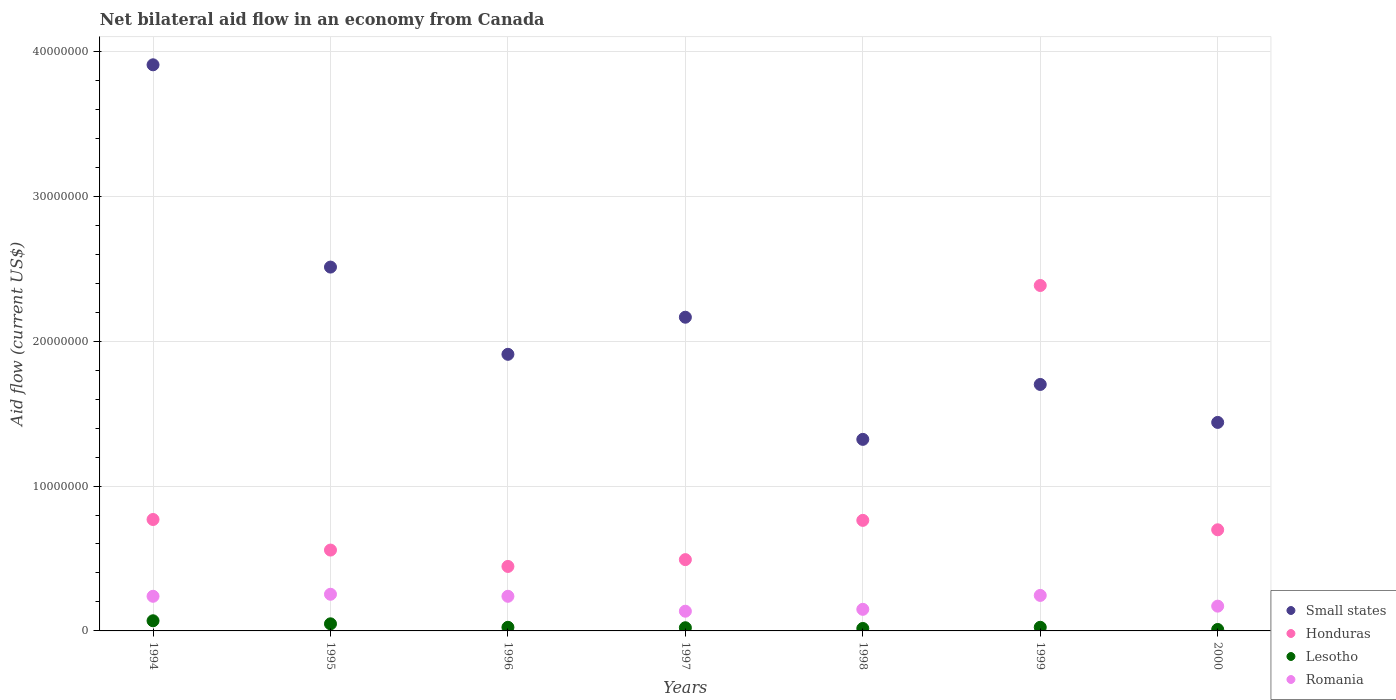How many different coloured dotlines are there?
Your answer should be compact. 4. What is the net bilateral aid flow in Lesotho in 1994?
Your response must be concise. 7.00e+05. Across all years, what is the maximum net bilateral aid flow in Honduras?
Keep it short and to the point. 2.38e+07. Across all years, what is the minimum net bilateral aid flow in Honduras?
Offer a very short reply. 4.45e+06. What is the total net bilateral aid flow in Small states in the graph?
Offer a terse response. 1.50e+08. What is the difference between the net bilateral aid flow in Honduras in 1996 and that in 2000?
Provide a succinct answer. -2.53e+06. What is the difference between the net bilateral aid flow in Lesotho in 1997 and the net bilateral aid flow in Honduras in 1996?
Your answer should be compact. -4.23e+06. What is the average net bilateral aid flow in Romania per year?
Provide a short and direct response. 2.05e+06. In the year 1998, what is the difference between the net bilateral aid flow in Lesotho and net bilateral aid flow in Small states?
Keep it short and to the point. -1.30e+07. What is the ratio of the net bilateral aid flow in Romania in 1994 to that in 1997?
Give a very brief answer. 1.76. Is the difference between the net bilateral aid flow in Lesotho in 1997 and 1998 greater than the difference between the net bilateral aid flow in Small states in 1997 and 1998?
Make the answer very short. No. What is the difference between the highest and the second highest net bilateral aid flow in Small states?
Give a very brief answer. 1.40e+07. What is the difference between the highest and the lowest net bilateral aid flow in Romania?
Your answer should be very brief. 1.17e+06. Is it the case that in every year, the sum of the net bilateral aid flow in Small states and net bilateral aid flow in Lesotho  is greater than the net bilateral aid flow in Romania?
Offer a terse response. Yes. Does the net bilateral aid flow in Small states monotonically increase over the years?
Make the answer very short. No. Is the net bilateral aid flow in Honduras strictly greater than the net bilateral aid flow in Romania over the years?
Ensure brevity in your answer.  Yes. How many dotlines are there?
Offer a very short reply. 4. Does the graph contain grids?
Your answer should be very brief. Yes. Where does the legend appear in the graph?
Your response must be concise. Bottom right. How are the legend labels stacked?
Your answer should be very brief. Vertical. What is the title of the graph?
Keep it short and to the point. Net bilateral aid flow in an economy from Canada. What is the label or title of the X-axis?
Give a very brief answer. Years. What is the Aid flow (current US$) in Small states in 1994?
Provide a succinct answer. 3.91e+07. What is the Aid flow (current US$) in Honduras in 1994?
Provide a succinct answer. 7.69e+06. What is the Aid flow (current US$) in Lesotho in 1994?
Your answer should be compact. 7.00e+05. What is the Aid flow (current US$) of Romania in 1994?
Offer a very short reply. 2.39e+06. What is the Aid flow (current US$) of Small states in 1995?
Offer a very short reply. 2.51e+07. What is the Aid flow (current US$) in Honduras in 1995?
Your answer should be compact. 5.58e+06. What is the Aid flow (current US$) in Lesotho in 1995?
Give a very brief answer. 4.90e+05. What is the Aid flow (current US$) in Romania in 1995?
Your answer should be compact. 2.53e+06. What is the Aid flow (current US$) in Small states in 1996?
Offer a terse response. 1.91e+07. What is the Aid flow (current US$) of Honduras in 1996?
Provide a short and direct response. 4.45e+06. What is the Aid flow (current US$) in Lesotho in 1996?
Your answer should be very brief. 2.50e+05. What is the Aid flow (current US$) in Romania in 1996?
Your answer should be very brief. 2.39e+06. What is the Aid flow (current US$) of Small states in 1997?
Keep it short and to the point. 2.16e+07. What is the Aid flow (current US$) in Honduras in 1997?
Provide a short and direct response. 4.92e+06. What is the Aid flow (current US$) of Lesotho in 1997?
Give a very brief answer. 2.20e+05. What is the Aid flow (current US$) of Romania in 1997?
Offer a very short reply. 1.36e+06. What is the Aid flow (current US$) in Small states in 1998?
Your answer should be very brief. 1.32e+07. What is the Aid flow (current US$) of Honduras in 1998?
Make the answer very short. 7.63e+06. What is the Aid flow (current US$) in Lesotho in 1998?
Give a very brief answer. 1.70e+05. What is the Aid flow (current US$) of Romania in 1998?
Provide a short and direct response. 1.49e+06. What is the Aid flow (current US$) of Small states in 1999?
Provide a short and direct response. 1.70e+07. What is the Aid flow (current US$) of Honduras in 1999?
Provide a short and direct response. 2.38e+07. What is the Aid flow (current US$) of Romania in 1999?
Provide a succinct answer. 2.45e+06. What is the Aid flow (current US$) in Small states in 2000?
Your answer should be very brief. 1.44e+07. What is the Aid flow (current US$) of Honduras in 2000?
Ensure brevity in your answer.  6.98e+06. What is the Aid flow (current US$) of Lesotho in 2000?
Make the answer very short. 1.00e+05. What is the Aid flow (current US$) of Romania in 2000?
Give a very brief answer. 1.71e+06. Across all years, what is the maximum Aid flow (current US$) of Small states?
Provide a short and direct response. 3.91e+07. Across all years, what is the maximum Aid flow (current US$) of Honduras?
Ensure brevity in your answer.  2.38e+07. Across all years, what is the maximum Aid flow (current US$) of Romania?
Your answer should be compact. 2.53e+06. Across all years, what is the minimum Aid flow (current US$) of Small states?
Make the answer very short. 1.32e+07. Across all years, what is the minimum Aid flow (current US$) in Honduras?
Your answer should be very brief. 4.45e+06. Across all years, what is the minimum Aid flow (current US$) in Lesotho?
Provide a succinct answer. 1.00e+05. Across all years, what is the minimum Aid flow (current US$) of Romania?
Provide a short and direct response. 1.36e+06. What is the total Aid flow (current US$) of Small states in the graph?
Ensure brevity in your answer.  1.50e+08. What is the total Aid flow (current US$) in Honduras in the graph?
Your answer should be very brief. 6.11e+07. What is the total Aid flow (current US$) in Lesotho in the graph?
Your answer should be compact. 2.18e+06. What is the total Aid flow (current US$) of Romania in the graph?
Your answer should be very brief. 1.43e+07. What is the difference between the Aid flow (current US$) in Small states in 1994 and that in 1995?
Provide a short and direct response. 1.40e+07. What is the difference between the Aid flow (current US$) of Honduras in 1994 and that in 1995?
Offer a very short reply. 2.11e+06. What is the difference between the Aid flow (current US$) in Romania in 1994 and that in 1995?
Ensure brevity in your answer.  -1.40e+05. What is the difference between the Aid flow (current US$) in Small states in 1994 and that in 1996?
Your answer should be very brief. 2.00e+07. What is the difference between the Aid flow (current US$) of Honduras in 1994 and that in 1996?
Offer a very short reply. 3.24e+06. What is the difference between the Aid flow (current US$) of Small states in 1994 and that in 1997?
Offer a terse response. 1.74e+07. What is the difference between the Aid flow (current US$) in Honduras in 1994 and that in 1997?
Offer a very short reply. 2.77e+06. What is the difference between the Aid flow (current US$) of Lesotho in 1994 and that in 1997?
Provide a succinct answer. 4.80e+05. What is the difference between the Aid flow (current US$) in Romania in 1994 and that in 1997?
Offer a very short reply. 1.03e+06. What is the difference between the Aid flow (current US$) in Small states in 1994 and that in 1998?
Provide a succinct answer. 2.58e+07. What is the difference between the Aid flow (current US$) in Lesotho in 1994 and that in 1998?
Provide a succinct answer. 5.30e+05. What is the difference between the Aid flow (current US$) of Small states in 1994 and that in 1999?
Provide a succinct answer. 2.21e+07. What is the difference between the Aid flow (current US$) of Honduras in 1994 and that in 1999?
Your answer should be very brief. -1.62e+07. What is the difference between the Aid flow (current US$) in Lesotho in 1994 and that in 1999?
Your response must be concise. 4.50e+05. What is the difference between the Aid flow (current US$) of Small states in 1994 and that in 2000?
Make the answer very short. 2.47e+07. What is the difference between the Aid flow (current US$) of Honduras in 1994 and that in 2000?
Your answer should be compact. 7.10e+05. What is the difference between the Aid flow (current US$) in Lesotho in 1994 and that in 2000?
Offer a very short reply. 6.00e+05. What is the difference between the Aid flow (current US$) in Romania in 1994 and that in 2000?
Offer a terse response. 6.80e+05. What is the difference between the Aid flow (current US$) in Small states in 1995 and that in 1996?
Provide a succinct answer. 6.02e+06. What is the difference between the Aid flow (current US$) in Honduras in 1995 and that in 1996?
Offer a very short reply. 1.13e+06. What is the difference between the Aid flow (current US$) in Romania in 1995 and that in 1996?
Ensure brevity in your answer.  1.40e+05. What is the difference between the Aid flow (current US$) of Small states in 1995 and that in 1997?
Make the answer very short. 3.46e+06. What is the difference between the Aid flow (current US$) in Romania in 1995 and that in 1997?
Your answer should be compact. 1.17e+06. What is the difference between the Aid flow (current US$) of Small states in 1995 and that in 1998?
Your answer should be compact. 1.19e+07. What is the difference between the Aid flow (current US$) in Honduras in 1995 and that in 1998?
Your answer should be very brief. -2.05e+06. What is the difference between the Aid flow (current US$) of Lesotho in 1995 and that in 1998?
Provide a short and direct response. 3.20e+05. What is the difference between the Aid flow (current US$) in Romania in 1995 and that in 1998?
Offer a terse response. 1.04e+06. What is the difference between the Aid flow (current US$) in Small states in 1995 and that in 1999?
Offer a terse response. 8.10e+06. What is the difference between the Aid flow (current US$) of Honduras in 1995 and that in 1999?
Keep it short and to the point. -1.83e+07. What is the difference between the Aid flow (current US$) in Lesotho in 1995 and that in 1999?
Ensure brevity in your answer.  2.40e+05. What is the difference between the Aid flow (current US$) of Romania in 1995 and that in 1999?
Provide a succinct answer. 8.00e+04. What is the difference between the Aid flow (current US$) of Small states in 1995 and that in 2000?
Make the answer very short. 1.07e+07. What is the difference between the Aid flow (current US$) of Honduras in 1995 and that in 2000?
Make the answer very short. -1.40e+06. What is the difference between the Aid flow (current US$) in Lesotho in 1995 and that in 2000?
Your response must be concise. 3.90e+05. What is the difference between the Aid flow (current US$) in Romania in 1995 and that in 2000?
Provide a short and direct response. 8.20e+05. What is the difference between the Aid flow (current US$) of Small states in 1996 and that in 1997?
Give a very brief answer. -2.56e+06. What is the difference between the Aid flow (current US$) of Honduras in 1996 and that in 1997?
Offer a terse response. -4.70e+05. What is the difference between the Aid flow (current US$) in Romania in 1996 and that in 1997?
Your answer should be very brief. 1.03e+06. What is the difference between the Aid flow (current US$) in Small states in 1996 and that in 1998?
Give a very brief answer. 5.87e+06. What is the difference between the Aid flow (current US$) in Honduras in 1996 and that in 1998?
Offer a very short reply. -3.18e+06. What is the difference between the Aid flow (current US$) of Lesotho in 1996 and that in 1998?
Your answer should be very brief. 8.00e+04. What is the difference between the Aid flow (current US$) in Small states in 1996 and that in 1999?
Keep it short and to the point. 2.08e+06. What is the difference between the Aid flow (current US$) in Honduras in 1996 and that in 1999?
Ensure brevity in your answer.  -1.94e+07. What is the difference between the Aid flow (current US$) of Romania in 1996 and that in 1999?
Provide a short and direct response. -6.00e+04. What is the difference between the Aid flow (current US$) in Small states in 1996 and that in 2000?
Keep it short and to the point. 4.70e+06. What is the difference between the Aid flow (current US$) of Honduras in 1996 and that in 2000?
Your response must be concise. -2.53e+06. What is the difference between the Aid flow (current US$) of Romania in 1996 and that in 2000?
Provide a succinct answer. 6.80e+05. What is the difference between the Aid flow (current US$) of Small states in 1997 and that in 1998?
Ensure brevity in your answer.  8.43e+06. What is the difference between the Aid flow (current US$) in Honduras in 1997 and that in 1998?
Provide a succinct answer. -2.71e+06. What is the difference between the Aid flow (current US$) of Small states in 1997 and that in 1999?
Ensure brevity in your answer.  4.64e+06. What is the difference between the Aid flow (current US$) of Honduras in 1997 and that in 1999?
Offer a terse response. -1.89e+07. What is the difference between the Aid flow (current US$) of Lesotho in 1997 and that in 1999?
Your answer should be very brief. -3.00e+04. What is the difference between the Aid flow (current US$) in Romania in 1997 and that in 1999?
Your answer should be very brief. -1.09e+06. What is the difference between the Aid flow (current US$) of Small states in 1997 and that in 2000?
Your answer should be compact. 7.26e+06. What is the difference between the Aid flow (current US$) in Honduras in 1997 and that in 2000?
Offer a terse response. -2.06e+06. What is the difference between the Aid flow (current US$) of Lesotho in 1997 and that in 2000?
Ensure brevity in your answer.  1.20e+05. What is the difference between the Aid flow (current US$) of Romania in 1997 and that in 2000?
Keep it short and to the point. -3.50e+05. What is the difference between the Aid flow (current US$) in Small states in 1998 and that in 1999?
Provide a short and direct response. -3.79e+06. What is the difference between the Aid flow (current US$) of Honduras in 1998 and that in 1999?
Ensure brevity in your answer.  -1.62e+07. What is the difference between the Aid flow (current US$) in Romania in 1998 and that in 1999?
Your answer should be very brief. -9.60e+05. What is the difference between the Aid flow (current US$) in Small states in 1998 and that in 2000?
Offer a terse response. -1.17e+06. What is the difference between the Aid flow (current US$) in Honduras in 1998 and that in 2000?
Provide a succinct answer. 6.50e+05. What is the difference between the Aid flow (current US$) in Small states in 1999 and that in 2000?
Offer a very short reply. 2.62e+06. What is the difference between the Aid flow (current US$) of Honduras in 1999 and that in 2000?
Your answer should be very brief. 1.69e+07. What is the difference between the Aid flow (current US$) in Lesotho in 1999 and that in 2000?
Offer a very short reply. 1.50e+05. What is the difference between the Aid flow (current US$) in Romania in 1999 and that in 2000?
Offer a terse response. 7.40e+05. What is the difference between the Aid flow (current US$) in Small states in 1994 and the Aid flow (current US$) in Honduras in 1995?
Your answer should be compact. 3.35e+07. What is the difference between the Aid flow (current US$) of Small states in 1994 and the Aid flow (current US$) of Lesotho in 1995?
Offer a terse response. 3.86e+07. What is the difference between the Aid flow (current US$) of Small states in 1994 and the Aid flow (current US$) of Romania in 1995?
Provide a short and direct response. 3.65e+07. What is the difference between the Aid flow (current US$) of Honduras in 1994 and the Aid flow (current US$) of Lesotho in 1995?
Provide a succinct answer. 7.20e+06. What is the difference between the Aid flow (current US$) in Honduras in 1994 and the Aid flow (current US$) in Romania in 1995?
Give a very brief answer. 5.16e+06. What is the difference between the Aid flow (current US$) of Lesotho in 1994 and the Aid flow (current US$) of Romania in 1995?
Give a very brief answer. -1.83e+06. What is the difference between the Aid flow (current US$) in Small states in 1994 and the Aid flow (current US$) in Honduras in 1996?
Provide a succinct answer. 3.46e+07. What is the difference between the Aid flow (current US$) in Small states in 1994 and the Aid flow (current US$) in Lesotho in 1996?
Make the answer very short. 3.88e+07. What is the difference between the Aid flow (current US$) of Small states in 1994 and the Aid flow (current US$) of Romania in 1996?
Your answer should be compact. 3.67e+07. What is the difference between the Aid flow (current US$) of Honduras in 1994 and the Aid flow (current US$) of Lesotho in 1996?
Offer a very short reply. 7.44e+06. What is the difference between the Aid flow (current US$) of Honduras in 1994 and the Aid flow (current US$) of Romania in 1996?
Provide a succinct answer. 5.30e+06. What is the difference between the Aid flow (current US$) of Lesotho in 1994 and the Aid flow (current US$) of Romania in 1996?
Make the answer very short. -1.69e+06. What is the difference between the Aid flow (current US$) of Small states in 1994 and the Aid flow (current US$) of Honduras in 1997?
Make the answer very short. 3.42e+07. What is the difference between the Aid flow (current US$) of Small states in 1994 and the Aid flow (current US$) of Lesotho in 1997?
Ensure brevity in your answer.  3.88e+07. What is the difference between the Aid flow (current US$) in Small states in 1994 and the Aid flow (current US$) in Romania in 1997?
Provide a short and direct response. 3.77e+07. What is the difference between the Aid flow (current US$) of Honduras in 1994 and the Aid flow (current US$) of Lesotho in 1997?
Give a very brief answer. 7.47e+06. What is the difference between the Aid flow (current US$) in Honduras in 1994 and the Aid flow (current US$) in Romania in 1997?
Ensure brevity in your answer.  6.33e+06. What is the difference between the Aid flow (current US$) in Lesotho in 1994 and the Aid flow (current US$) in Romania in 1997?
Ensure brevity in your answer.  -6.60e+05. What is the difference between the Aid flow (current US$) in Small states in 1994 and the Aid flow (current US$) in Honduras in 1998?
Your answer should be very brief. 3.14e+07. What is the difference between the Aid flow (current US$) in Small states in 1994 and the Aid flow (current US$) in Lesotho in 1998?
Provide a succinct answer. 3.89e+07. What is the difference between the Aid flow (current US$) of Small states in 1994 and the Aid flow (current US$) of Romania in 1998?
Keep it short and to the point. 3.76e+07. What is the difference between the Aid flow (current US$) of Honduras in 1994 and the Aid flow (current US$) of Lesotho in 1998?
Keep it short and to the point. 7.52e+06. What is the difference between the Aid flow (current US$) of Honduras in 1994 and the Aid flow (current US$) of Romania in 1998?
Offer a very short reply. 6.20e+06. What is the difference between the Aid flow (current US$) in Lesotho in 1994 and the Aid flow (current US$) in Romania in 1998?
Ensure brevity in your answer.  -7.90e+05. What is the difference between the Aid flow (current US$) in Small states in 1994 and the Aid flow (current US$) in Honduras in 1999?
Give a very brief answer. 1.52e+07. What is the difference between the Aid flow (current US$) in Small states in 1994 and the Aid flow (current US$) in Lesotho in 1999?
Keep it short and to the point. 3.88e+07. What is the difference between the Aid flow (current US$) of Small states in 1994 and the Aid flow (current US$) of Romania in 1999?
Make the answer very short. 3.66e+07. What is the difference between the Aid flow (current US$) in Honduras in 1994 and the Aid flow (current US$) in Lesotho in 1999?
Make the answer very short. 7.44e+06. What is the difference between the Aid flow (current US$) in Honduras in 1994 and the Aid flow (current US$) in Romania in 1999?
Offer a very short reply. 5.24e+06. What is the difference between the Aid flow (current US$) in Lesotho in 1994 and the Aid flow (current US$) in Romania in 1999?
Your answer should be very brief. -1.75e+06. What is the difference between the Aid flow (current US$) in Small states in 1994 and the Aid flow (current US$) in Honduras in 2000?
Offer a very short reply. 3.21e+07. What is the difference between the Aid flow (current US$) in Small states in 1994 and the Aid flow (current US$) in Lesotho in 2000?
Make the answer very short. 3.90e+07. What is the difference between the Aid flow (current US$) in Small states in 1994 and the Aid flow (current US$) in Romania in 2000?
Offer a terse response. 3.74e+07. What is the difference between the Aid flow (current US$) of Honduras in 1994 and the Aid flow (current US$) of Lesotho in 2000?
Your answer should be compact. 7.59e+06. What is the difference between the Aid flow (current US$) of Honduras in 1994 and the Aid flow (current US$) of Romania in 2000?
Ensure brevity in your answer.  5.98e+06. What is the difference between the Aid flow (current US$) of Lesotho in 1994 and the Aid flow (current US$) of Romania in 2000?
Your answer should be very brief. -1.01e+06. What is the difference between the Aid flow (current US$) of Small states in 1995 and the Aid flow (current US$) of Honduras in 1996?
Keep it short and to the point. 2.07e+07. What is the difference between the Aid flow (current US$) in Small states in 1995 and the Aid flow (current US$) in Lesotho in 1996?
Give a very brief answer. 2.49e+07. What is the difference between the Aid flow (current US$) in Small states in 1995 and the Aid flow (current US$) in Romania in 1996?
Provide a succinct answer. 2.27e+07. What is the difference between the Aid flow (current US$) in Honduras in 1995 and the Aid flow (current US$) in Lesotho in 1996?
Make the answer very short. 5.33e+06. What is the difference between the Aid flow (current US$) in Honduras in 1995 and the Aid flow (current US$) in Romania in 1996?
Ensure brevity in your answer.  3.19e+06. What is the difference between the Aid flow (current US$) in Lesotho in 1995 and the Aid flow (current US$) in Romania in 1996?
Provide a succinct answer. -1.90e+06. What is the difference between the Aid flow (current US$) in Small states in 1995 and the Aid flow (current US$) in Honduras in 1997?
Your response must be concise. 2.02e+07. What is the difference between the Aid flow (current US$) of Small states in 1995 and the Aid flow (current US$) of Lesotho in 1997?
Your answer should be very brief. 2.49e+07. What is the difference between the Aid flow (current US$) of Small states in 1995 and the Aid flow (current US$) of Romania in 1997?
Offer a terse response. 2.38e+07. What is the difference between the Aid flow (current US$) in Honduras in 1995 and the Aid flow (current US$) in Lesotho in 1997?
Your response must be concise. 5.36e+06. What is the difference between the Aid flow (current US$) of Honduras in 1995 and the Aid flow (current US$) of Romania in 1997?
Provide a short and direct response. 4.22e+06. What is the difference between the Aid flow (current US$) in Lesotho in 1995 and the Aid flow (current US$) in Romania in 1997?
Keep it short and to the point. -8.70e+05. What is the difference between the Aid flow (current US$) of Small states in 1995 and the Aid flow (current US$) of Honduras in 1998?
Offer a very short reply. 1.75e+07. What is the difference between the Aid flow (current US$) of Small states in 1995 and the Aid flow (current US$) of Lesotho in 1998?
Ensure brevity in your answer.  2.49e+07. What is the difference between the Aid flow (current US$) in Small states in 1995 and the Aid flow (current US$) in Romania in 1998?
Your response must be concise. 2.36e+07. What is the difference between the Aid flow (current US$) in Honduras in 1995 and the Aid flow (current US$) in Lesotho in 1998?
Offer a very short reply. 5.41e+06. What is the difference between the Aid flow (current US$) in Honduras in 1995 and the Aid flow (current US$) in Romania in 1998?
Offer a terse response. 4.09e+06. What is the difference between the Aid flow (current US$) of Small states in 1995 and the Aid flow (current US$) of Honduras in 1999?
Give a very brief answer. 1.27e+06. What is the difference between the Aid flow (current US$) in Small states in 1995 and the Aid flow (current US$) in Lesotho in 1999?
Your response must be concise. 2.49e+07. What is the difference between the Aid flow (current US$) of Small states in 1995 and the Aid flow (current US$) of Romania in 1999?
Your answer should be very brief. 2.27e+07. What is the difference between the Aid flow (current US$) of Honduras in 1995 and the Aid flow (current US$) of Lesotho in 1999?
Make the answer very short. 5.33e+06. What is the difference between the Aid flow (current US$) in Honduras in 1995 and the Aid flow (current US$) in Romania in 1999?
Ensure brevity in your answer.  3.13e+06. What is the difference between the Aid flow (current US$) in Lesotho in 1995 and the Aid flow (current US$) in Romania in 1999?
Provide a short and direct response. -1.96e+06. What is the difference between the Aid flow (current US$) in Small states in 1995 and the Aid flow (current US$) in Honduras in 2000?
Offer a very short reply. 1.81e+07. What is the difference between the Aid flow (current US$) in Small states in 1995 and the Aid flow (current US$) in Lesotho in 2000?
Offer a very short reply. 2.50e+07. What is the difference between the Aid flow (current US$) of Small states in 1995 and the Aid flow (current US$) of Romania in 2000?
Keep it short and to the point. 2.34e+07. What is the difference between the Aid flow (current US$) of Honduras in 1995 and the Aid flow (current US$) of Lesotho in 2000?
Make the answer very short. 5.48e+06. What is the difference between the Aid flow (current US$) in Honduras in 1995 and the Aid flow (current US$) in Romania in 2000?
Provide a succinct answer. 3.87e+06. What is the difference between the Aid flow (current US$) in Lesotho in 1995 and the Aid flow (current US$) in Romania in 2000?
Your answer should be very brief. -1.22e+06. What is the difference between the Aid flow (current US$) in Small states in 1996 and the Aid flow (current US$) in Honduras in 1997?
Offer a very short reply. 1.42e+07. What is the difference between the Aid flow (current US$) in Small states in 1996 and the Aid flow (current US$) in Lesotho in 1997?
Your answer should be compact. 1.89e+07. What is the difference between the Aid flow (current US$) of Small states in 1996 and the Aid flow (current US$) of Romania in 1997?
Offer a terse response. 1.77e+07. What is the difference between the Aid flow (current US$) in Honduras in 1996 and the Aid flow (current US$) in Lesotho in 1997?
Your answer should be very brief. 4.23e+06. What is the difference between the Aid flow (current US$) in Honduras in 1996 and the Aid flow (current US$) in Romania in 1997?
Keep it short and to the point. 3.09e+06. What is the difference between the Aid flow (current US$) in Lesotho in 1996 and the Aid flow (current US$) in Romania in 1997?
Keep it short and to the point. -1.11e+06. What is the difference between the Aid flow (current US$) of Small states in 1996 and the Aid flow (current US$) of Honduras in 1998?
Keep it short and to the point. 1.15e+07. What is the difference between the Aid flow (current US$) of Small states in 1996 and the Aid flow (current US$) of Lesotho in 1998?
Keep it short and to the point. 1.89e+07. What is the difference between the Aid flow (current US$) in Small states in 1996 and the Aid flow (current US$) in Romania in 1998?
Your response must be concise. 1.76e+07. What is the difference between the Aid flow (current US$) in Honduras in 1996 and the Aid flow (current US$) in Lesotho in 1998?
Give a very brief answer. 4.28e+06. What is the difference between the Aid flow (current US$) in Honduras in 1996 and the Aid flow (current US$) in Romania in 1998?
Give a very brief answer. 2.96e+06. What is the difference between the Aid flow (current US$) of Lesotho in 1996 and the Aid flow (current US$) of Romania in 1998?
Your answer should be compact. -1.24e+06. What is the difference between the Aid flow (current US$) in Small states in 1996 and the Aid flow (current US$) in Honduras in 1999?
Offer a very short reply. -4.75e+06. What is the difference between the Aid flow (current US$) of Small states in 1996 and the Aid flow (current US$) of Lesotho in 1999?
Your answer should be very brief. 1.88e+07. What is the difference between the Aid flow (current US$) in Small states in 1996 and the Aid flow (current US$) in Romania in 1999?
Your answer should be compact. 1.66e+07. What is the difference between the Aid flow (current US$) in Honduras in 1996 and the Aid flow (current US$) in Lesotho in 1999?
Provide a succinct answer. 4.20e+06. What is the difference between the Aid flow (current US$) of Lesotho in 1996 and the Aid flow (current US$) of Romania in 1999?
Ensure brevity in your answer.  -2.20e+06. What is the difference between the Aid flow (current US$) of Small states in 1996 and the Aid flow (current US$) of Honduras in 2000?
Keep it short and to the point. 1.21e+07. What is the difference between the Aid flow (current US$) in Small states in 1996 and the Aid flow (current US$) in Lesotho in 2000?
Your answer should be compact. 1.90e+07. What is the difference between the Aid flow (current US$) in Small states in 1996 and the Aid flow (current US$) in Romania in 2000?
Your answer should be very brief. 1.74e+07. What is the difference between the Aid flow (current US$) of Honduras in 1996 and the Aid flow (current US$) of Lesotho in 2000?
Your response must be concise. 4.35e+06. What is the difference between the Aid flow (current US$) of Honduras in 1996 and the Aid flow (current US$) of Romania in 2000?
Provide a succinct answer. 2.74e+06. What is the difference between the Aid flow (current US$) of Lesotho in 1996 and the Aid flow (current US$) of Romania in 2000?
Your answer should be compact. -1.46e+06. What is the difference between the Aid flow (current US$) in Small states in 1997 and the Aid flow (current US$) in Honduras in 1998?
Keep it short and to the point. 1.40e+07. What is the difference between the Aid flow (current US$) of Small states in 1997 and the Aid flow (current US$) of Lesotho in 1998?
Offer a very short reply. 2.15e+07. What is the difference between the Aid flow (current US$) of Small states in 1997 and the Aid flow (current US$) of Romania in 1998?
Your response must be concise. 2.02e+07. What is the difference between the Aid flow (current US$) of Honduras in 1997 and the Aid flow (current US$) of Lesotho in 1998?
Keep it short and to the point. 4.75e+06. What is the difference between the Aid flow (current US$) of Honduras in 1997 and the Aid flow (current US$) of Romania in 1998?
Your answer should be compact. 3.43e+06. What is the difference between the Aid flow (current US$) of Lesotho in 1997 and the Aid flow (current US$) of Romania in 1998?
Your answer should be compact. -1.27e+06. What is the difference between the Aid flow (current US$) in Small states in 1997 and the Aid flow (current US$) in Honduras in 1999?
Make the answer very short. -2.19e+06. What is the difference between the Aid flow (current US$) in Small states in 1997 and the Aid flow (current US$) in Lesotho in 1999?
Make the answer very short. 2.14e+07. What is the difference between the Aid flow (current US$) in Small states in 1997 and the Aid flow (current US$) in Romania in 1999?
Ensure brevity in your answer.  1.92e+07. What is the difference between the Aid flow (current US$) in Honduras in 1997 and the Aid flow (current US$) in Lesotho in 1999?
Provide a succinct answer. 4.67e+06. What is the difference between the Aid flow (current US$) in Honduras in 1997 and the Aid flow (current US$) in Romania in 1999?
Ensure brevity in your answer.  2.47e+06. What is the difference between the Aid flow (current US$) in Lesotho in 1997 and the Aid flow (current US$) in Romania in 1999?
Provide a succinct answer. -2.23e+06. What is the difference between the Aid flow (current US$) of Small states in 1997 and the Aid flow (current US$) of Honduras in 2000?
Provide a short and direct response. 1.47e+07. What is the difference between the Aid flow (current US$) of Small states in 1997 and the Aid flow (current US$) of Lesotho in 2000?
Give a very brief answer. 2.16e+07. What is the difference between the Aid flow (current US$) of Small states in 1997 and the Aid flow (current US$) of Romania in 2000?
Provide a succinct answer. 1.99e+07. What is the difference between the Aid flow (current US$) of Honduras in 1997 and the Aid flow (current US$) of Lesotho in 2000?
Provide a succinct answer. 4.82e+06. What is the difference between the Aid flow (current US$) of Honduras in 1997 and the Aid flow (current US$) of Romania in 2000?
Offer a terse response. 3.21e+06. What is the difference between the Aid flow (current US$) in Lesotho in 1997 and the Aid flow (current US$) in Romania in 2000?
Give a very brief answer. -1.49e+06. What is the difference between the Aid flow (current US$) of Small states in 1998 and the Aid flow (current US$) of Honduras in 1999?
Keep it short and to the point. -1.06e+07. What is the difference between the Aid flow (current US$) in Small states in 1998 and the Aid flow (current US$) in Lesotho in 1999?
Give a very brief answer. 1.30e+07. What is the difference between the Aid flow (current US$) of Small states in 1998 and the Aid flow (current US$) of Romania in 1999?
Give a very brief answer. 1.08e+07. What is the difference between the Aid flow (current US$) of Honduras in 1998 and the Aid flow (current US$) of Lesotho in 1999?
Offer a terse response. 7.38e+06. What is the difference between the Aid flow (current US$) in Honduras in 1998 and the Aid flow (current US$) in Romania in 1999?
Your answer should be very brief. 5.18e+06. What is the difference between the Aid flow (current US$) in Lesotho in 1998 and the Aid flow (current US$) in Romania in 1999?
Offer a terse response. -2.28e+06. What is the difference between the Aid flow (current US$) of Small states in 1998 and the Aid flow (current US$) of Honduras in 2000?
Your answer should be very brief. 6.24e+06. What is the difference between the Aid flow (current US$) of Small states in 1998 and the Aid flow (current US$) of Lesotho in 2000?
Offer a terse response. 1.31e+07. What is the difference between the Aid flow (current US$) of Small states in 1998 and the Aid flow (current US$) of Romania in 2000?
Offer a terse response. 1.15e+07. What is the difference between the Aid flow (current US$) in Honduras in 1998 and the Aid flow (current US$) in Lesotho in 2000?
Provide a succinct answer. 7.53e+06. What is the difference between the Aid flow (current US$) in Honduras in 1998 and the Aid flow (current US$) in Romania in 2000?
Give a very brief answer. 5.92e+06. What is the difference between the Aid flow (current US$) of Lesotho in 1998 and the Aid flow (current US$) of Romania in 2000?
Your answer should be very brief. -1.54e+06. What is the difference between the Aid flow (current US$) of Small states in 1999 and the Aid flow (current US$) of Honduras in 2000?
Ensure brevity in your answer.  1.00e+07. What is the difference between the Aid flow (current US$) in Small states in 1999 and the Aid flow (current US$) in Lesotho in 2000?
Offer a terse response. 1.69e+07. What is the difference between the Aid flow (current US$) in Small states in 1999 and the Aid flow (current US$) in Romania in 2000?
Make the answer very short. 1.53e+07. What is the difference between the Aid flow (current US$) of Honduras in 1999 and the Aid flow (current US$) of Lesotho in 2000?
Give a very brief answer. 2.37e+07. What is the difference between the Aid flow (current US$) in Honduras in 1999 and the Aid flow (current US$) in Romania in 2000?
Give a very brief answer. 2.21e+07. What is the difference between the Aid flow (current US$) of Lesotho in 1999 and the Aid flow (current US$) of Romania in 2000?
Offer a terse response. -1.46e+06. What is the average Aid flow (current US$) in Small states per year?
Offer a very short reply. 2.14e+07. What is the average Aid flow (current US$) in Honduras per year?
Your answer should be compact. 8.73e+06. What is the average Aid flow (current US$) of Lesotho per year?
Your answer should be very brief. 3.11e+05. What is the average Aid flow (current US$) of Romania per year?
Make the answer very short. 2.05e+06. In the year 1994, what is the difference between the Aid flow (current US$) of Small states and Aid flow (current US$) of Honduras?
Make the answer very short. 3.14e+07. In the year 1994, what is the difference between the Aid flow (current US$) of Small states and Aid flow (current US$) of Lesotho?
Make the answer very short. 3.84e+07. In the year 1994, what is the difference between the Aid flow (current US$) in Small states and Aid flow (current US$) in Romania?
Provide a succinct answer. 3.67e+07. In the year 1994, what is the difference between the Aid flow (current US$) of Honduras and Aid flow (current US$) of Lesotho?
Your answer should be compact. 6.99e+06. In the year 1994, what is the difference between the Aid flow (current US$) of Honduras and Aid flow (current US$) of Romania?
Provide a short and direct response. 5.30e+06. In the year 1994, what is the difference between the Aid flow (current US$) of Lesotho and Aid flow (current US$) of Romania?
Keep it short and to the point. -1.69e+06. In the year 1995, what is the difference between the Aid flow (current US$) in Small states and Aid flow (current US$) in Honduras?
Your answer should be compact. 1.95e+07. In the year 1995, what is the difference between the Aid flow (current US$) in Small states and Aid flow (current US$) in Lesotho?
Make the answer very short. 2.46e+07. In the year 1995, what is the difference between the Aid flow (current US$) in Small states and Aid flow (current US$) in Romania?
Ensure brevity in your answer.  2.26e+07. In the year 1995, what is the difference between the Aid flow (current US$) in Honduras and Aid flow (current US$) in Lesotho?
Your answer should be compact. 5.09e+06. In the year 1995, what is the difference between the Aid flow (current US$) of Honduras and Aid flow (current US$) of Romania?
Give a very brief answer. 3.05e+06. In the year 1995, what is the difference between the Aid flow (current US$) of Lesotho and Aid flow (current US$) of Romania?
Your answer should be very brief. -2.04e+06. In the year 1996, what is the difference between the Aid flow (current US$) in Small states and Aid flow (current US$) in Honduras?
Provide a succinct answer. 1.46e+07. In the year 1996, what is the difference between the Aid flow (current US$) of Small states and Aid flow (current US$) of Lesotho?
Keep it short and to the point. 1.88e+07. In the year 1996, what is the difference between the Aid flow (current US$) of Small states and Aid flow (current US$) of Romania?
Offer a very short reply. 1.67e+07. In the year 1996, what is the difference between the Aid flow (current US$) in Honduras and Aid flow (current US$) in Lesotho?
Offer a terse response. 4.20e+06. In the year 1996, what is the difference between the Aid flow (current US$) of Honduras and Aid flow (current US$) of Romania?
Offer a very short reply. 2.06e+06. In the year 1996, what is the difference between the Aid flow (current US$) in Lesotho and Aid flow (current US$) in Romania?
Offer a terse response. -2.14e+06. In the year 1997, what is the difference between the Aid flow (current US$) of Small states and Aid flow (current US$) of Honduras?
Provide a short and direct response. 1.67e+07. In the year 1997, what is the difference between the Aid flow (current US$) in Small states and Aid flow (current US$) in Lesotho?
Your answer should be very brief. 2.14e+07. In the year 1997, what is the difference between the Aid flow (current US$) in Small states and Aid flow (current US$) in Romania?
Make the answer very short. 2.03e+07. In the year 1997, what is the difference between the Aid flow (current US$) of Honduras and Aid flow (current US$) of Lesotho?
Make the answer very short. 4.70e+06. In the year 1997, what is the difference between the Aid flow (current US$) of Honduras and Aid flow (current US$) of Romania?
Your response must be concise. 3.56e+06. In the year 1997, what is the difference between the Aid flow (current US$) in Lesotho and Aid flow (current US$) in Romania?
Provide a short and direct response. -1.14e+06. In the year 1998, what is the difference between the Aid flow (current US$) in Small states and Aid flow (current US$) in Honduras?
Make the answer very short. 5.59e+06. In the year 1998, what is the difference between the Aid flow (current US$) in Small states and Aid flow (current US$) in Lesotho?
Give a very brief answer. 1.30e+07. In the year 1998, what is the difference between the Aid flow (current US$) of Small states and Aid flow (current US$) of Romania?
Ensure brevity in your answer.  1.17e+07. In the year 1998, what is the difference between the Aid flow (current US$) of Honduras and Aid flow (current US$) of Lesotho?
Ensure brevity in your answer.  7.46e+06. In the year 1998, what is the difference between the Aid flow (current US$) in Honduras and Aid flow (current US$) in Romania?
Make the answer very short. 6.14e+06. In the year 1998, what is the difference between the Aid flow (current US$) in Lesotho and Aid flow (current US$) in Romania?
Keep it short and to the point. -1.32e+06. In the year 1999, what is the difference between the Aid flow (current US$) in Small states and Aid flow (current US$) in Honduras?
Make the answer very short. -6.83e+06. In the year 1999, what is the difference between the Aid flow (current US$) in Small states and Aid flow (current US$) in Lesotho?
Your answer should be compact. 1.68e+07. In the year 1999, what is the difference between the Aid flow (current US$) of Small states and Aid flow (current US$) of Romania?
Offer a very short reply. 1.46e+07. In the year 1999, what is the difference between the Aid flow (current US$) in Honduras and Aid flow (current US$) in Lesotho?
Your answer should be very brief. 2.36e+07. In the year 1999, what is the difference between the Aid flow (current US$) in Honduras and Aid flow (current US$) in Romania?
Make the answer very short. 2.14e+07. In the year 1999, what is the difference between the Aid flow (current US$) of Lesotho and Aid flow (current US$) of Romania?
Ensure brevity in your answer.  -2.20e+06. In the year 2000, what is the difference between the Aid flow (current US$) in Small states and Aid flow (current US$) in Honduras?
Your answer should be compact. 7.41e+06. In the year 2000, what is the difference between the Aid flow (current US$) of Small states and Aid flow (current US$) of Lesotho?
Keep it short and to the point. 1.43e+07. In the year 2000, what is the difference between the Aid flow (current US$) of Small states and Aid flow (current US$) of Romania?
Keep it short and to the point. 1.27e+07. In the year 2000, what is the difference between the Aid flow (current US$) in Honduras and Aid flow (current US$) in Lesotho?
Provide a succinct answer. 6.88e+06. In the year 2000, what is the difference between the Aid flow (current US$) of Honduras and Aid flow (current US$) of Romania?
Provide a succinct answer. 5.27e+06. In the year 2000, what is the difference between the Aid flow (current US$) in Lesotho and Aid flow (current US$) in Romania?
Your answer should be compact. -1.61e+06. What is the ratio of the Aid flow (current US$) of Small states in 1994 to that in 1995?
Give a very brief answer. 1.56. What is the ratio of the Aid flow (current US$) of Honduras in 1994 to that in 1995?
Your answer should be very brief. 1.38. What is the ratio of the Aid flow (current US$) of Lesotho in 1994 to that in 1995?
Make the answer very short. 1.43. What is the ratio of the Aid flow (current US$) of Romania in 1994 to that in 1995?
Your response must be concise. 0.94. What is the ratio of the Aid flow (current US$) in Small states in 1994 to that in 1996?
Your answer should be very brief. 2.05. What is the ratio of the Aid flow (current US$) of Honduras in 1994 to that in 1996?
Provide a short and direct response. 1.73. What is the ratio of the Aid flow (current US$) in Lesotho in 1994 to that in 1996?
Make the answer very short. 2.8. What is the ratio of the Aid flow (current US$) of Romania in 1994 to that in 1996?
Your answer should be very brief. 1. What is the ratio of the Aid flow (current US$) of Small states in 1994 to that in 1997?
Provide a succinct answer. 1.8. What is the ratio of the Aid flow (current US$) of Honduras in 1994 to that in 1997?
Your response must be concise. 1.56. What is the ratio of the Aid flow (current US$) in Lesotho in 1994 to that in 1997?
Offer a very short reply. 3.18. What is the ratio of the Aid flow (current US$) in Romania in 1994 to that in 1997?
Provide a short and direct response. 1.76. What is the ratio of the Aid flow (current US$) in Small states in 1994 to that in 1998?
Keep it short and to the point. 2.96. What is the ratio of the Aid flow (current US$) of Honduras in 1994 to that in 1998?
Provide a short and direct response. 1.01. What is the ratio of the Aid flow (current US$) in Lesotho in 1994 to that in 1998?
Provide a short and direct response. 4.12. What is the ratio of the Aid flow (current US$) in Romania in 1994 to that in 1998?
Your answer should be compact. 1.6. What is the ratio of the Aid flow (current US$) of Small states in 1994 to that in 1999?
Your answer should be very brief. 2.3. What is the ratio of the Aid flow (current US$) in Honduras in 1994 to that in 1999?
Provide a short and direct response. 0.32. What is the ratio of the Aid flow (current US$) in Lesotho in 1994 to that in 1999?
Provide a succinct answer. 2.8. What is the ratio of the Aid flow (current US$) in Romania in 1994 to that in 1999?
Give a very brief answer. 0.98. What is the ratio of the Aid flow (current US$) of Small states in 1994 to that in 2000?
Your response must be concise. 2.72. What is the ratio of the Aid flow (current US$) in Honduras in 1994 to that in 2000?
Offer a terse response. 1.1. What is the ratio of the Aid flow (current US$) of Romania in 1994 to that in 2000?
Keep it short and to the point. 1.4. What is the ratio of the Aid flow (current US$) of Small states in 1995 to that in 1996?
Give a very brief answer. 1.32. What is the ratio of the Aid flow (current US$) in Honduras in 1995 to that in 1996?
Your answer should be compact. 1.25. What is the ratio of the Aid flow (current US$) of Lesotho in 1995 to that in 1996?
Your answer should be very brief. 1.96. What is the ratio of the Aid flow (current US$) in Romania in 1995 to that in 1996?
Your response must be concise. 1.06. What is the ratio of the Aid flow (current US$) of Small states in 1995 to that in 1997?
Provide a succinct answer. 1.16. What is the ratio of the Aid flow (current US$) of Honduras in 1995 to that in 1997?
Provide a succinct answer. 1.13. What is the ratio of the Aid flow (current US$) in Lesotho in 1995 to that in 1997?
Keep it short and to the point. 2.23. What is the ratio of the Aid flow (current US$) in Romania in 1995 to that in 1997?
Provide a succinct answer. 1.86. What is the ratio of the Aid flow (current US$) of Small states in 1995 to that in 1998?
Offer a very short reply. 1.9. What is the ratio of the Aid flow (current US$) of Honduras in 1995 to that in 1998?
Provide a succinct answer. 0.73. What is the ratio of the Aid flow (current US$) in Lesotho in 1995 to that in 1998?
Your answer should be compact. 2.88. What is the ratio of the Aid flow (current US$) in Romania in 1995 to that in 1998?
Your answer should be very brief. 1.7. What is the ratio of the Aid flow (current US$) in Small states in 1995 to that in 1999?
Provide a succinct answer. 1.48. What is the ratio of the Aid flow (current US$) of Honduras in 1995 to that in 1999?
Offer a terse response. 0.23. What is the ratio of the Aid flow (current US$) of Lesotho in 1995 to that in 1999?
Ensure brevity in your answer.  1.96. What is the ratio of the Aid flow (current US$) of Romania in 1995 to that in 1999?
Make the answer very short. 1.03. What is the ratio of the Aid flow (current US$) in Small states in 1995 to that in 2000?
Your answer should be compact. 1.75. What is the ratio of the Aid flow (current US$) of Honduras in 1995 to that in 2000?
Offer a terse response. 0.8. What is the ratio of the Aid flow (current US$) of Lesotho in 1995 to that in 2000?
Your answer should be compact. 4.9. What is the ratio of the Aid flow (current US$) of Romania in 1995 to that in 2000?
Your answer should be compact. 1.48. What is the ratio of the Aid flow (current US$) in Small states in 1996 to that in 1997?
Give a very brief answer. 0.88. What is the ratio of the Aid flow (current US$) of Honduras in 1996 to that in 1997?
Make the answer very short. 0.9. What is the ratio of the Aid flow (current US$) in Lesotho in 1996 to that in 1997?
Provide a short and direct response. 1.14. What is the ratio of the Aid flow (current US$) of Romania in 1996 to that in 1997?
Your answer should be very brief. 1.76. What is the ratio of the Aid flow (current US$) in Small states in 1996 to that in 1998?
Your response must be concise. 1.44. What is the ratio of the Aid flow (current US$) in Honduras in 1996 to that in 1998?
Your response must be concise. 0.58. What is the ratio of the Aid flow (current US$) of Lesotho in 1996 to that in 1998?
Ensure brevity in your answer.  1.47. What is the ratio of the Aid flow (current US$) in Romania in 1996 to that in 1998?
Provide a short and direct response. 1.6. What is the ratio of the Aid flow (current US$) of Small states in 1996 to that in 1999?
Provide a succinct answer. 1.12. What is the ratio of the Aid flow (current US$) in Honduras in 1996 to that in 1999?
Your answer should be compact. 0.19. What is the ratio of the Aid flow (current US$) of Romania in 1996 to that in 1999?
Your answer should be compact. 0.98. What is the ratio of the Aid flow (current US$) in Small states in 1996 to that in 2000?
Your response must be concise. 1.33. What is the ratio of the Aid flow (current US$) in Honduras in 1996 to that in 2000?
Keep it short and to the point. 0.64. What is the ratio of the Aid flow (current US$) of Romania in 1996 to that in 2000?
Give a very brief answer. 1.4. What is the ratio of the Aid flow (current US$) in Small states in 1997 to that in 1998?
Offer a very short reply. 1.64. What is the ratio of the Aid flow (current US$) of Honduras in 1997 to that in 1998?
Provide a short and direct response. 0.64. What is the ratio of the Aid flow (current US$) in Lesotho in 1997 to that in 1998?
Offer a very short reply. 1.29. What is the ratio of the Aid flow (current US$) in Romania in 1997 to that in 1998?
Offer a terse response. 0.91. What is the ratio of the Aid flow (current US$) in Small states in 1997 to that in 1999?
Your answer should be compact. 1.27. What is the ratio of the Aid flow (current US$) in Honduras in 1997 to that in 1999?
Your answer should be compact. 0.21. What is the ratio of the Aid flow (current US$) in Romania in 1997 to that in 1999?
Your answer should be compact. 0.56. What is the ratio of the Aid flow (current US$) of Small states in 1997 to that in 2000?
Ensure brevity in your answer.  1.5. What is the ratio of the Aid flow (current US$) of Honduras in 1997 to that in 2000?
Offer a terse response. 0.7. What is the ratio of the Aid flow (current US$) in Romania in 1997 to that in 2000?
Provide a short and direct response. 0.8. What is the ratio of the Aid flow (current US$) of Small states in 1998 to that in 1999?
Offer a terse response. 0.78. What is the ratio of the Aid flow (current US$) of Honduras in 1998 to that in 1999?
Your response must be concise. 0.32. What is the ratio of the Aid flow (current US$) in Lesotho in 1998 to that in 1999?
Provide a short and direct response. 0.68. What is the ratio of the Aid flow (current US$) of Romania in 1998 to that in 1999?
Your answer should be very brief. 0.61. What is the ratio of the Aid flow (current US$) of Small states in 1998 to that in 2000?
Ensure brevity in your answer.  0.92. What is the ratio of the Aid flow (current US$) in Honduras in 1998 to that in 2000?
Offer a very short reply. 1.09. What is the ratio of the Aid flow (current US$) of Lesotho in 1998 to that in 2000?
Offer a very short reply. 1.7. What is the ratio of the Aid flow (current US$) in Romania in 1998 to that in 2000?
Give a very brief answer. 0.87. What is the ratio of the Aid flow (current US$) of Small states in 1999 to that in 2000?
Your answer should be compact. 1.18. What is the ratio of the Aid flow (current US$) in Honduras in 1999 to that in 2000?
Offer a very short reply. 3.42. What is the ratio of the Aid flow (current US$) in Romania in 1999 to that in 2000?
Provide a succinct answer. 1.43. What is the difference between the highest and the second highest Aid flow (current US$) of Small states?
Offer a terse response. 1.40e+07. What is the difference between the highest and the second highest Aid flow (current US$) in Honduras?
Provide a short and direct response. 1.62e+07. What is the difference between the highest and the second highest Aid flow (current US$) of Lesotho?
Make the answer very short. 2.10e+05. What is the difference between the highest and the second highest Aid flow (current US$) of Romania?
Your response must be concise. 8.00e+04. What is the difference between the highest and the lowest Aid flow (current US$) of Small states?
Make the answer very short. 2.58e+07. What is the difference between the highest and the lowest Aid flow (current US$) of Honduras?
Offer a very short reply. 1.94e+07. What is the difference between the highest and the lowest Aid flow (current US$) in Romania?
Provide a succinct answer. 1.17e+06. 